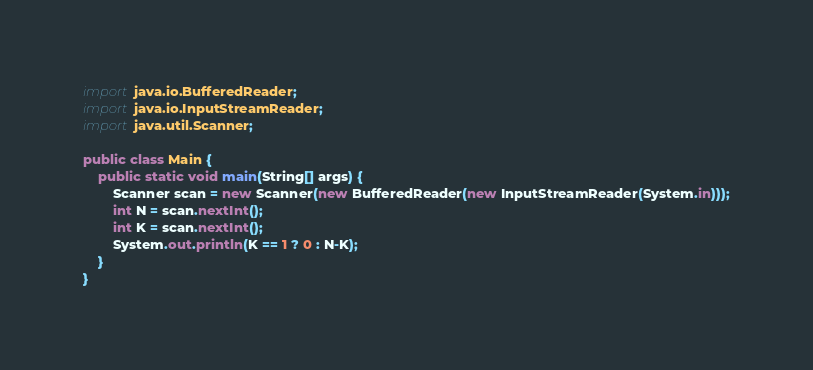Convert code to text. <code><loc_0><loc_0><loc_500><loc_500><_Java_>import java.io.BufferedReader;
import java.io.InputStreamReader;
import java.util.Scanner;

public class Main {
    public static void main(String[] args) {
        Scanner scan = new Scanner(new BufferedReader(new InputStreamReader(System.in)));
        int N = scan.nextInt();
        int K = scan.nextInt();
        System.out.println(K == 1 ? 0 : N-K);
    }
}</code> 